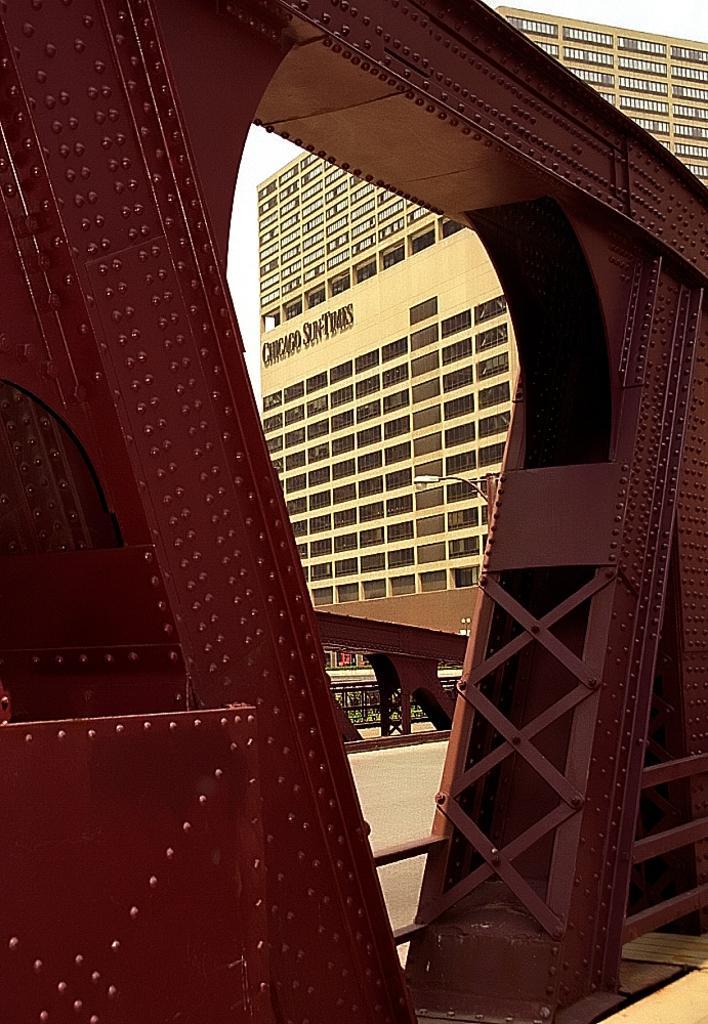How would you summarize this image in a sentence or two? In this image I can see there is iron frame, there is a building in the backdrop and it has windows and the sky is clear. 